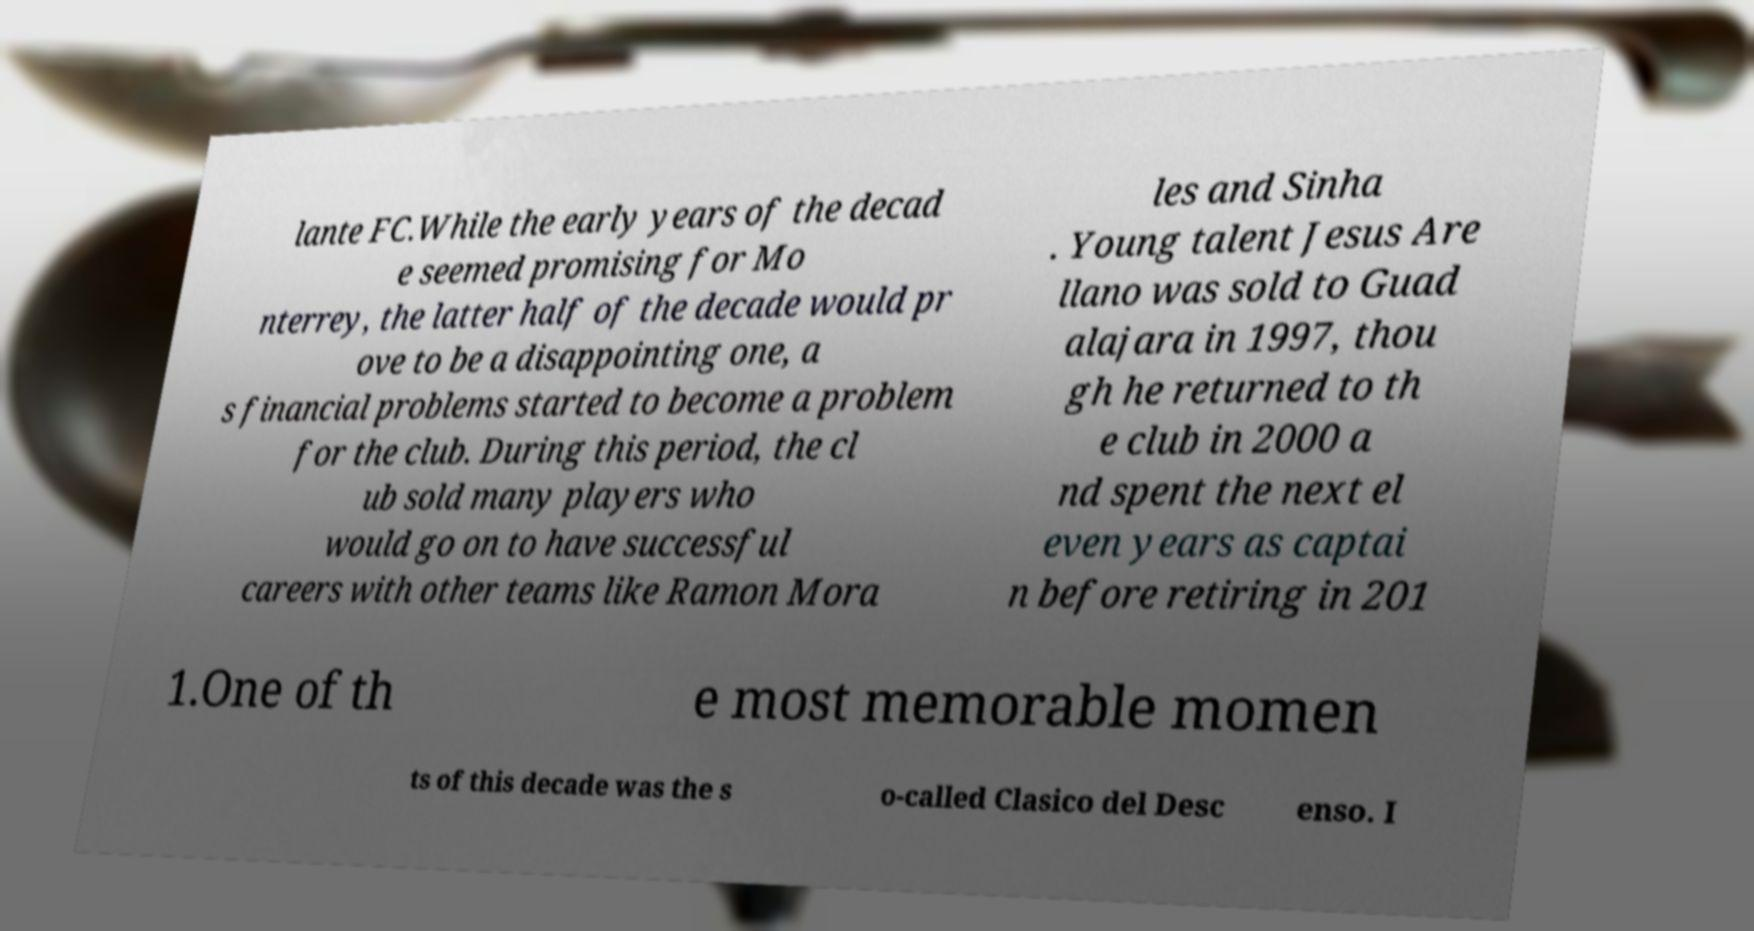I need the written content from this picture converted into text. Can you do that? lante FC.While the early years of the decad e seemed promising for Mo nterrey, the latter half of the decade would pr ove to be a disappointing one, a s financial problems started to become a problem for the club. During this period, the cl ub sold many players who would go on to have successful careers with other teams like Ramon Mora les and Sinha . Young talent Jesus Are llano was sold to Guad alajara in 1997, thou gh he returned to th e club in 2000 a nd spent the next el even years as captai n before retiring in 201 1.One of th e most memorable momen ts of this decade was the s o-called Clasico del Desc enso. I 